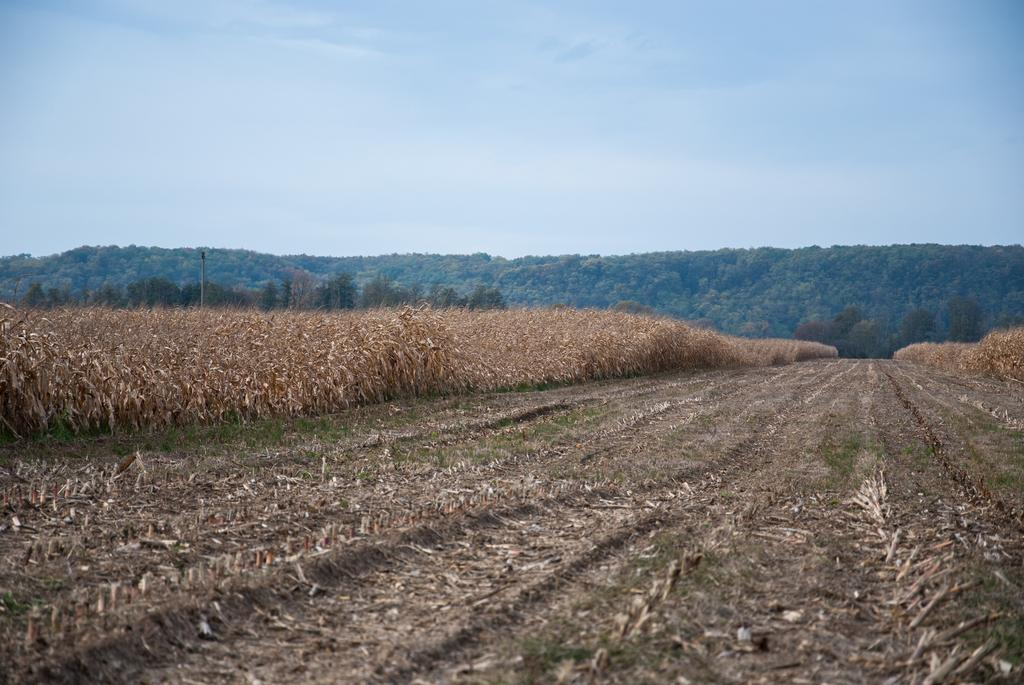What type of plants are in the image? There are dried plants in the image. What can be seen in the background of the image? There are trees in the background of the image. What color is the sky in the image? The sky is blue in the image. How many pigs are visible in the image? There are no pigs present in the image. What type of cake is being served at the gate in the image? There is no cake or gate present in the image. 